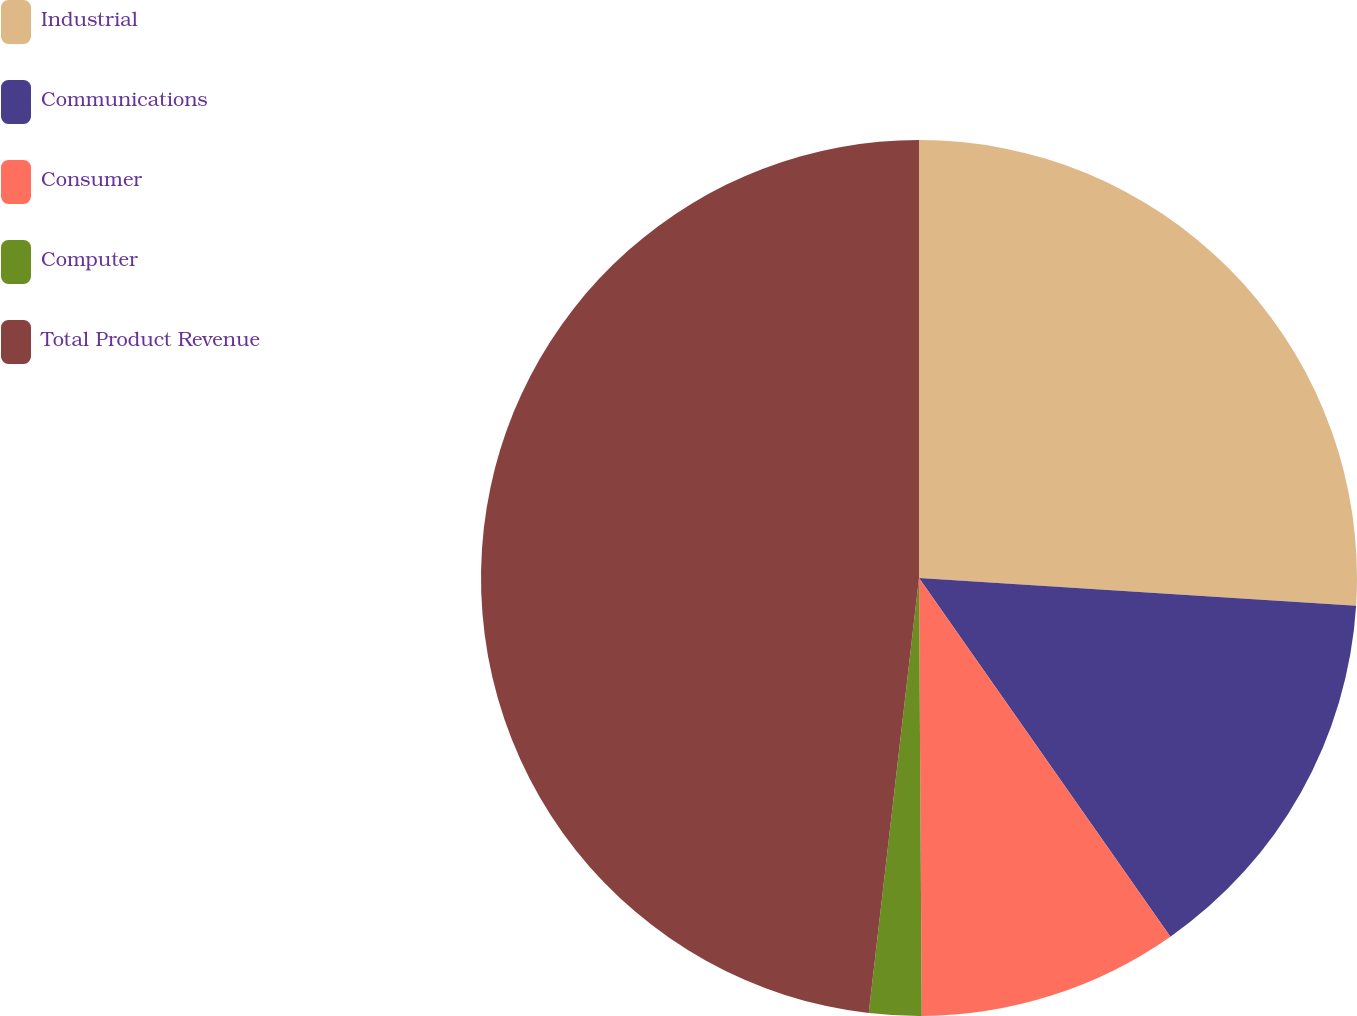Convert chart. <chart><loc_0><loc_0><loc_500><loc_500><pie_chart><fcel>Industrial<fcel>Communications<fcel>Consumer<fcel>Computer<fcel>Total Product Revenue<nl><fcel>26.01%<fcel>14.26%<fcel>9.63%<fcel>1.93%<fcel>48.17%<nl></chart> 